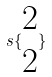Convert formula to latex. <formula><loc_0><loc_0><loc_500><loc_500>s \{ \begin{matrix} 2 \\ 2 \end{matrix} \}</formula> 